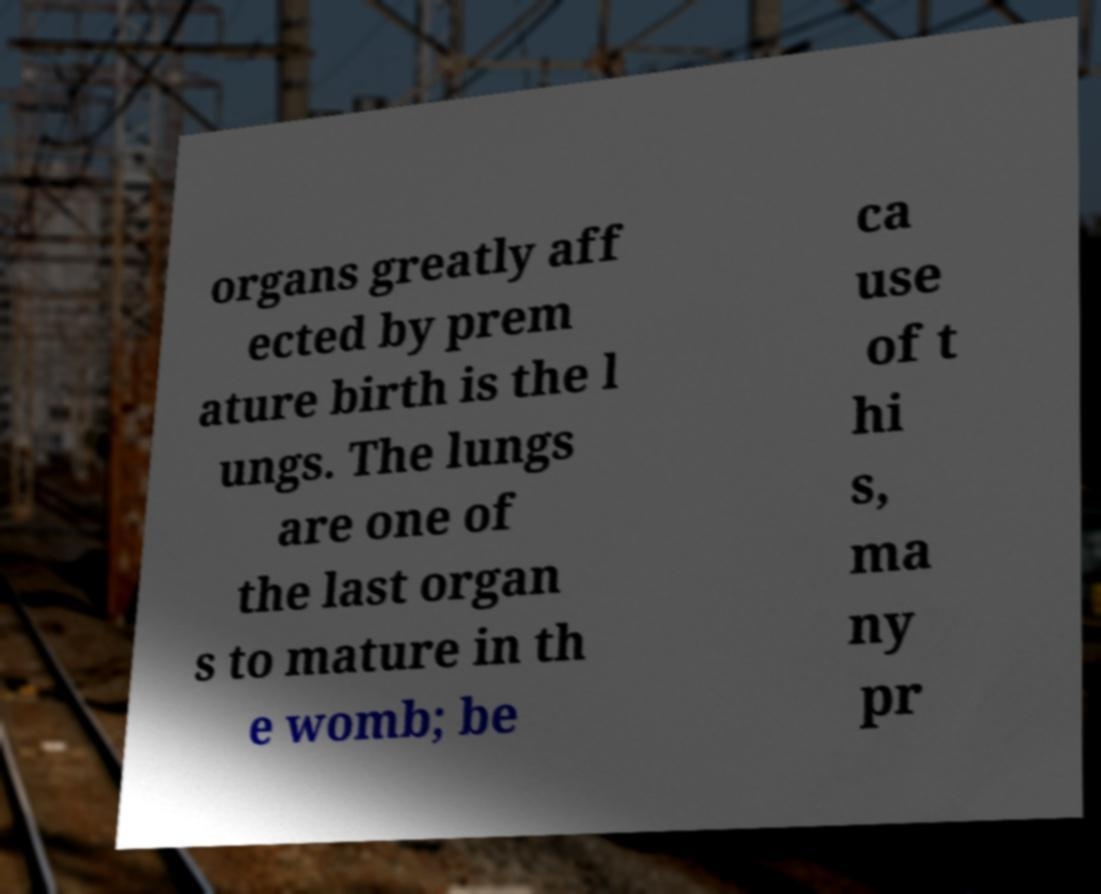Could you extract and type out the text from this image? organs greatly aff ected by prem ature birth is the l ungs. The lungs are one of the last organ s to mature in th e womb; be ca use of t hi s, ma ny pr 